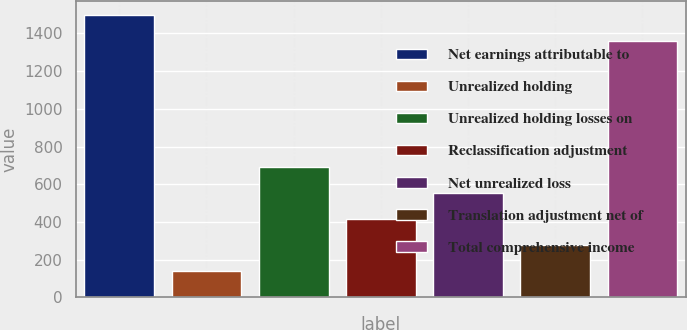Convert chart. <chart><loc_0><loc_0><loc_500><loc_500><bar_chart><fcel>Net earnings attributable to<fcel>Unrealized holding<fcel>Unrealized holding losses on<fcel>Reclassification adjustment<fcel>Net unrealized loss<fcel>Translation adjustment net of<fcel>Total comprehensive income<nl><fcel>1498.54<fcel>138.74<fcel>692.1<fcel>415.42<fcel>553.76<fcel>277.08<fcel>1360.2<nl></chart> 